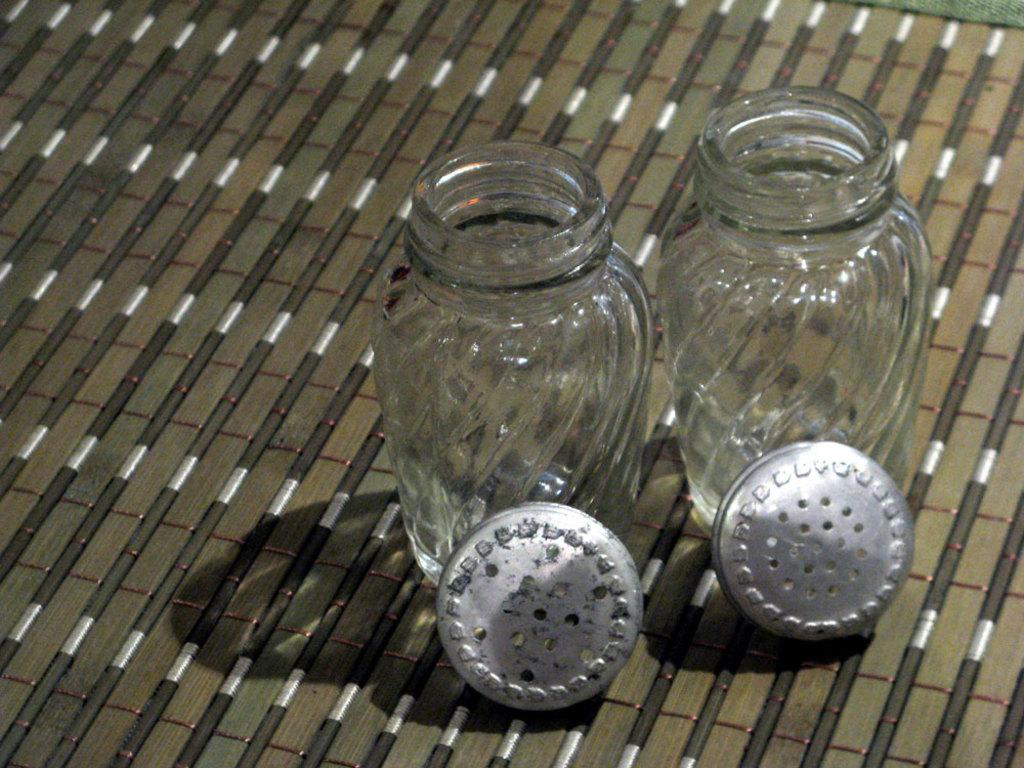How many jars are visible in the image? There are two jars in the image. What is the status of the lids on the jars? The lids of the jars are opened. Where are the lids placed in relation to the jars? The lids are placed beside the jars. How many goldfish are swimming in the jars in the image? There are no goldfish present in the image; it only features two jars with opened lids. What is the height of the jars in the image? The provided facts do not mention the height of the jars, so it cannot be determined from the image. 